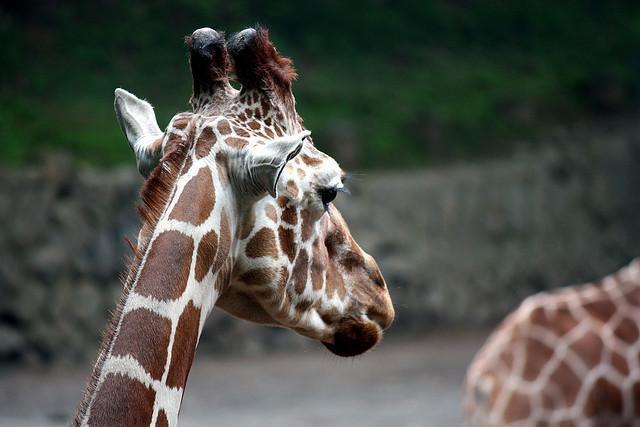How many years does the giraffe have?
Give a very brief answer. 2. How many giraffes are visible?
Give a very brief answer. 2. How many people are in the picture?
Give a very brief answer. 0. 